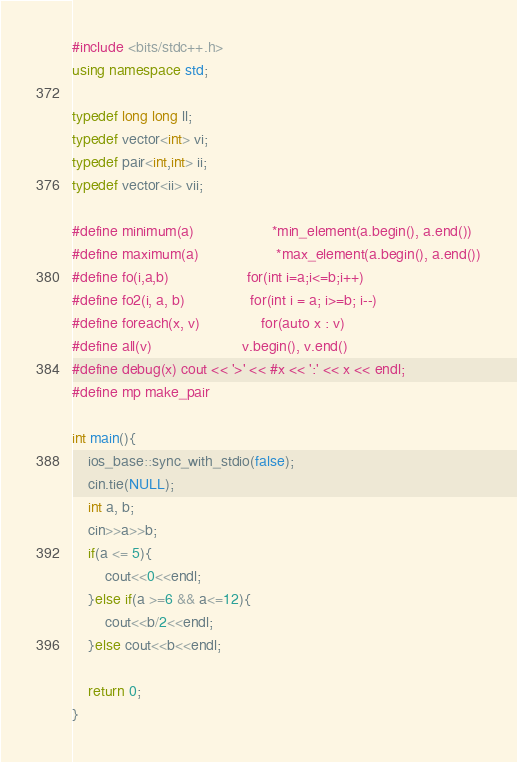Convert code to text. <code><loc_0><loc_0><loc_500><loc_500><_C++_>#include <bits/stdc++.h>
using namespace std;

typedef long long ll;
typedef vector<int> vi;
typedef pair<int,int> ii;
typedef vector<ii> vii;

#define minimum(a)					*min_element(a.begin(), a.end())
#define maximum(a)					*max_element(a.begin(), a.end())
#define fo(i,a,b)                   for(int i=a;i<=b;i++)
#define fo2(i, a, b)                for(int i = a; i>=b; i--)
#define foreach(x, v)               for(auto x : v)
#define all(v)                      v.begin(), v.end()
#define debug(x) cout << '>' << #x << ':' << x << endl;
#define mp make_pair

int main(){
    ios_base::sync_with_stdio(false);
    cin.tie(NULL);
    int a, b;
    cin>>a>>b;
    if(a <= 5){
        cout<<0<<endl;
    }else if(a >=6 && a<=12){
        cout<<b/2<<endl;
    }else cout<<b<<endl;
    
    return 0;
}
</code> 